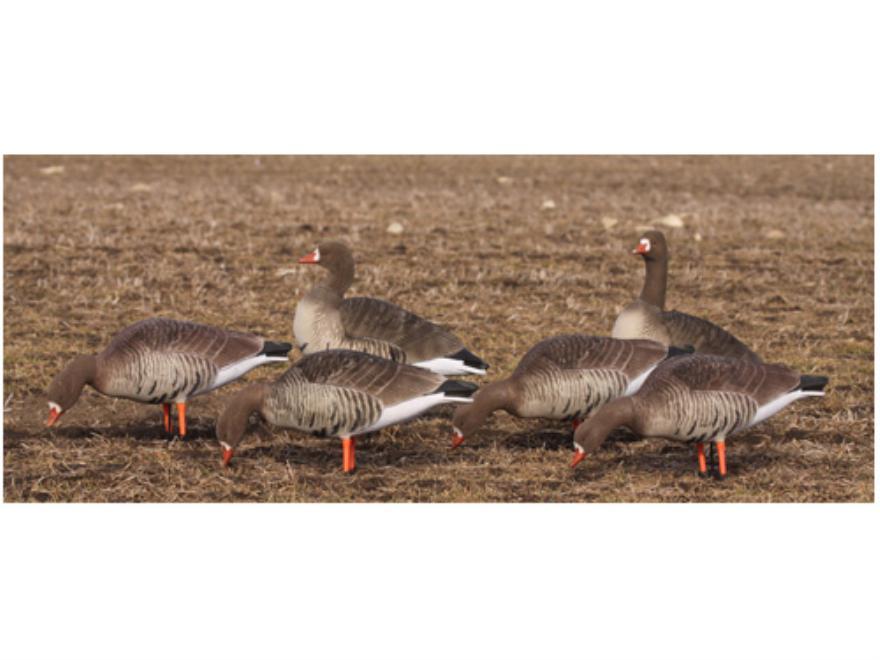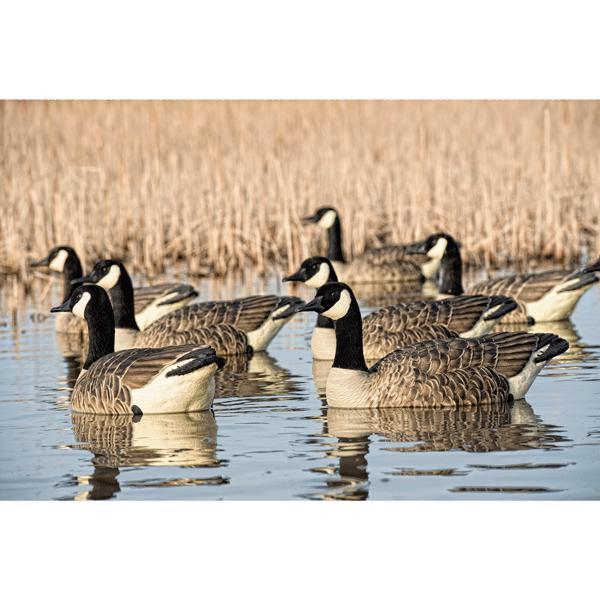The first image is the image on the left, the second image is the image on the right. Considering the images on both sides, is "Ducks in the left image are in water." valid? Answer yes or no. No. 